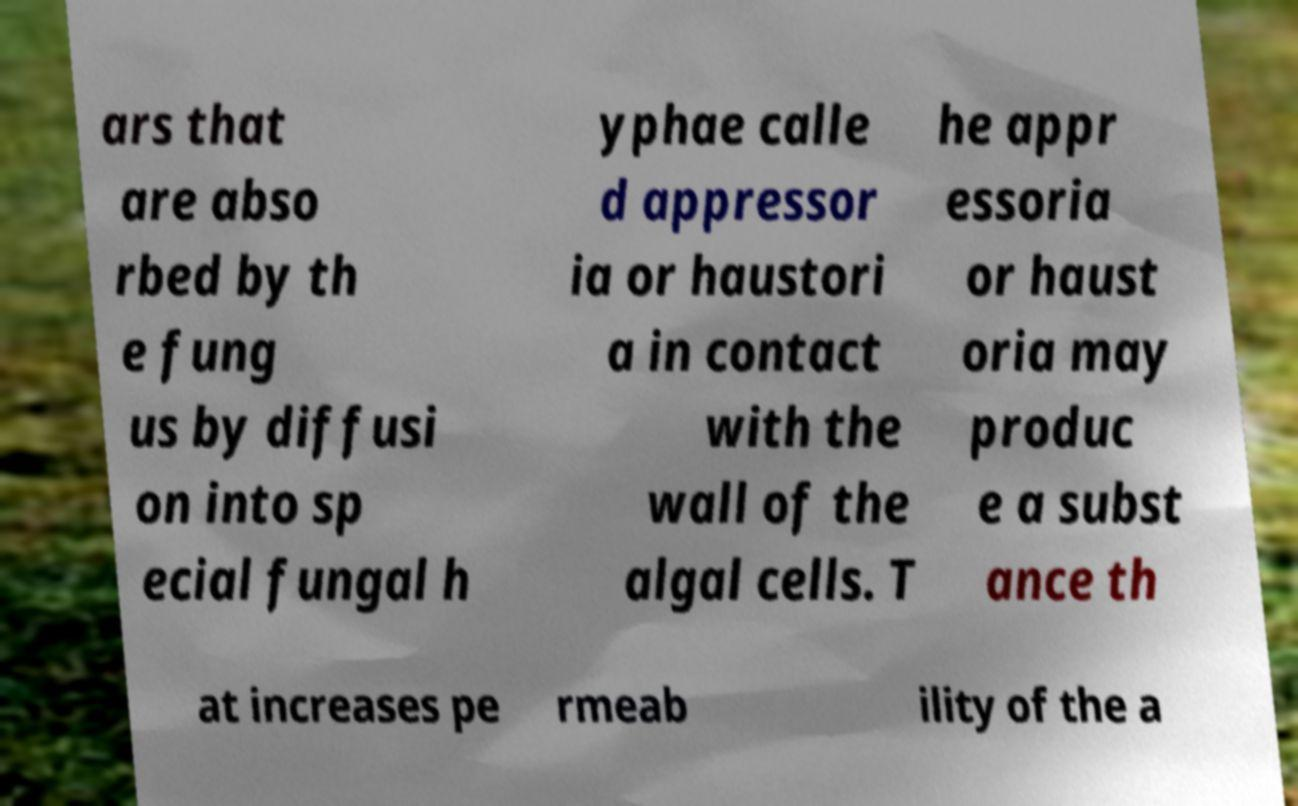What messages or text are displayed in this image? I need them in a readable, typed format. ars that are abso rbed by th e fung us by diffusi on into sp ecial fungal h yphae calle d appressor ia or haustori a in contact with the wall of the algal cells. T he appr essoria or haust oria may produc e a subst ance th at increases pe rmeab ility of the a 